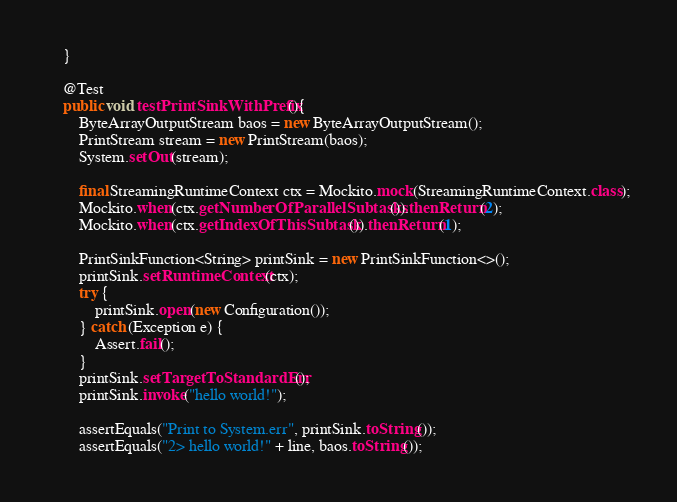Convert code to text. <code><loc_0><loc_0><loc_500><loc_500><_Java_>	}

	@Test
	public void testPrintSinkWithPrefix(){
		ByteArrayOutputStream baos = new ByteArrayOutputStream();
		PrintStream stream = new PrintStream(baos);
		System.setOut(stream);

		final StreamingRuntimeContext ctx = Mockito.mock(StreamingRuntimeContext.class);
		Mockito.when(ctx.getNumberOfParallelSubtasks()).thenReturn(2);
		Mockito.when(ctx.getIndexOfThisSubtask()).thenReturn(1);

		PrintSinkFunction<String> printSink = new PrintSinkFunction<>();
		printSink.setRuntimeContext(ctx);
		try {
			printSink.open(new Configuration());
		} catch (Exception e) {
			Assert.fail();
		}
		printSink.setTargetToStandardErr();
		printSink.invoke("hello world!");

		assertEquals("Print to System.err", printSink.toString());
		assertEquals("2> hello world!" + line, baos.toString());
</code> 